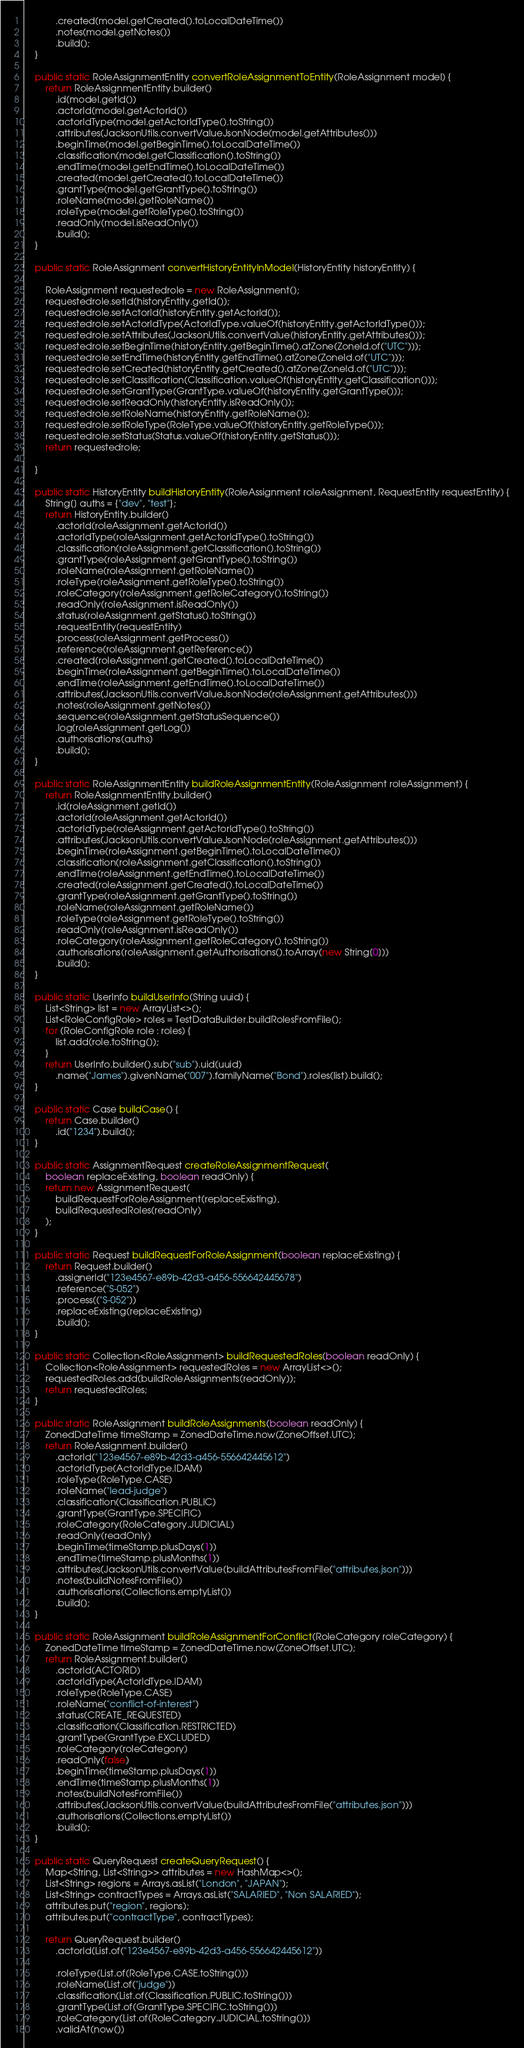Convert code to text. <code><loc_0><loc_0><loc_500><loc_500><_Java_>            .created(model.getCreated().toLocalDateTime())
            .notes(model.getNotes())
            .build();
    }

    public static RoleAssignmentEntity convertRoleAssignmentToEntity(RoleAssignment model) {
        return RoleAssignmentEntity.builder()
            .id(model.getId())
            .actorId(model.getActorId())
            .actorIdType(model.getActorIdType().toString())
            .attributes(JacksonUtils.convertValueJsonNode(model.getAttributes()))
            .beginTime(model.getBeginTime().toLocalDateTime())
            .classification(model.getClassification().toString())
            .endTime(model.getEndTime().toLocalDateTime())
            .created(model.getCreated().toLocalDateTime())
            .grantType(model.getGrantType().toString())
            .roleName(model.getRoleName())
            .roleType(model.getRoleType().toString())
            .readOnly(model.isReadOnly())
            .build();
    }

    public static RoleAssignment convertHistoryEntityInModel(HistoryEntity historyEntity) {

        RoleAssignment requestedrole = new RoleAssignment();
        requestedrole.setId(historyEntity.getId());
        requestedrole.setActorId(historyEntity.getActorId());
        requestedrole.setActorIdType(ActorIdType.valueOf(historyEntity.getActorIdType()));
        requestedrole.setAttributes(JacksonUtils.convertValue(historyEntity.getAttributes()));
        requestedrole.setBeginTime(historyEntity.getBeginTime().atZone(ZoneId.of("UTC")));
        requestedrole.setEndTime(historyEntity.getEndTime().atZone(ZoneId.of("UTC")));
        requestedrole.setCreated(historyEntity.getCreated().atZone(ZoneId.of("UTC")));
        requestedrole.setClassification(Classification.valueOf(historyEntity.getClassification()));
        requestedrole.setGrantType(GrantType.valueOf(historyEntity.getGrantType()));
        requestedrole.setReadOnly(historyEntity.isReadOnly());
        requestedrole.setRoleName(historyEntity.getRoleName());
        requestedrole.setRoleType(RoleType.valueOf(historyEntity.getRoleType()));
        requestedrole.setStatus(Status.valueOf(historyEntity.getStatus()));
        return requestedrole;

    }

    public static HistoryEntity buildHistoryEntity(RoleAssignment roleAssignment, RequestEntity requestEntity) {
        String[] auths = {"dev", "test"};
        return HistoryEntity.builder()
            .actorId(roleAssignment.getActorId())
            .actorIdType(roleAssignment.getActorIdType().toString())
            .classification(roleAssignment.getClassification().toString())
            .grantType(roleAssignment.getGrantType().toString())
            .roleName(roleAssignment.getRoleName())
            .roleType(roleAssignment.getRoleType().toString())
            .roleCategory(roleAssignment.getRoleCategory().toString())
            .readOnly(roleAssignment.isReadOnly())
            .status(roleAssignment.getStatus().toString())
            .requestEntity(requestEntity)
            .process(roleAssignment.getProcess())
            .reference(roleAssignment.getReference())
            .created(roleAssignment.getCreated().toLocalDateTime())
            .beginTime(roleAssignment.getBeginTime().toLocalDateTime())
            .endTime(roleAssignment.getEndTime().toLocalDateTime())
            .attributes(JacksonUtils.convertValueJsonNode(roleAssignment.getAttributes()))
            .notes(roleAssignment.getNotes())
            .sequence(roleAssignment.getStatusSequence())
            .log(roleAssignment.getLog())
            .authorisations(auths)
            .build();
    }

    public static RoleAssignmentEntity buildRoleAssignmentEntity(RoleAssignment roleAssignment) {
        return RoleAssignmentEntity.builder()
            .id(roleAssignment.getId())
            .actorId(roleAssignment.getActorId())
            .actorIdType(roleAssignment.getActorIdType().toString())
            .attributes(JacksonUtils.convertValueJsonNode(roleAssignment.getAttributes()))
            .beginTime(roleAssignment.getBeginTime().toLocalDateTime())
            .classification(roleAssignment.getClassification().toString())
            .endTime(roleAssignment.getEndTime().toLocalDateTime())
            .created(roleAssignment.getCreated().toLocalDateTime())
            .grantType(roleAssignment.getGrantType().toString())
            .roleName(roleAssignment.getRoleName())
            .roleType(roleAssignment.getRoleType().toString())
            .readOnly(roleAssignment.isReadOnly())
            .roleCategory(roleAssignment.getRoleCategory().toString())
            .authorisations(roleAssignment.getAuthorisations().toArray(new String[0]))
            .build();
    }

    public static UserInfo buildUserInfo(String uuid) {
        List<String> list = new ArrayList<>();
        List<RoleConfigRole> roles = TestDataBuilder.buildRolesFromFile();
        for (RoleConfigRole role : roles) {
            list.add(role.toString());
        }
        return UserInfo.builder().sub("sub").uid(uuid)
            .name("James").givenName("007").familyName("Bond").roles(list).build();
    }

    public static Case buildCase() {
        return Case.builder()
            .id("1234").build();
    }

    public static AssignmentRequest createRoleAssignmentRequest(
        boolean replaceExisting, boolean readOnly) {
        return new AssignmentRequest(
            buildRequestForRoleAssignment(replaceExisting),
            buildRequestedRoles(readOnly)
        );
    }

    public static Request buildRequestForRoleAssignment(boolean replaceExisting) {
        return Request.builder()
            .assignerId("123e4567-e89b-42d3-a456-556642445678")
            .reference("S-052")
            .process(("S-052"))
            .replaceExisting(replaceExisting)
            .build();
    }

    public static Collection<RoleAssignment> buildRequestedRoles(boolean readOnly) {
        Collection<RoleAssignment> requestedRoles = new ArrayList<>();
        requestedRoles.add(buildRoleAssignments(readOnly));
        return requestedRoles;
    }

    public static RoleAssignment buildRoleAssignments(boolean readOnly) {
        ZonedDateTime timeStamp = ZonedDateTime.now(ZoneOffset.UTC);
        return RoleAssignment.builder()
            .actorId("123e4567-e89b-42d3-a456-556642445612")
            .actorIdType(ActorIdType.IDAM)
            .roleType(RoleType.CASE)
            .roleName("lead-judge")
            .classification(Classification.PUBLIC)
            .grantType(GrantType.SPECIFIC)
            .roleCategory(RoleCategory.JUDICIAL)
            .readOnly(readOnly)
            .beginTime(timeStamp.plusDays(1))
            .endTime(timeStamp.plusMonths(1))
            .attributes(JacksonUtils.convertValue(buildAttributesFromFile("attributes.json")))
            .notes(buildNotesFromFile())
            .authorisations(Collections.emptyList())
            .build();
    }

    public static RoleAssignment buildRoleAssignmentForConflict(RoleCategory roleCategory) {
        ZonedDateTime timeStamp = ZonedDateTime.now(ZoneOffset.UTC);
        return RoleAssignment.builder()
            .actorId(ACTORID)
            .actorIdType(ActorIdType.IDAM)
            .roleType(RoleType.CASE)
            .roleName("conflict-of-interest")
            .status(CREATE_REQUESTED)
            .classification(Classification.RESTRICTED)
            .grantType(GrantType.EXCLUDED)
            .roleCategory(roleCategory)
            .readOnly(false)
            .beginTime(timeStamp.plusDays(1))
            .endTime(timeStamp.plusMonths(1))
            .notes(buildNotesFromFile())
            .attributes(JacksonUtils.convertValue(buildAttributesFromFile("attributes.json")))
            .authorisations(Collections.emptyList())
            .build();
    }

    public static QueryRequest createQueryRequest() {
        Map<String, List<String>> attributes = new HashMap<>();
        List<String> regions = Arrays.asList("London", "JAPAN");
        List<String> contractTypes = Arrays.asList("SALARIED", "Non SALARIED");
        attributes.put("region", regions);
        attributes.put("contractType", contractTypes);

        return QueryRequest.builder()
            .actorId(List.of("123e4567-e89b-42d3-a456-556642445612"))

            .roleType(List.of(RoleType.CASE.toString()))
            .roleName(List.of("judge"))
            .classification(List.of(Classification.PUBLIC.toString()))
            .grantType(List.of(GrantType.SPECIFIC.toString()))
            .roleCategory(List.of(RoleCategory.JUDICIAL.toString()))
            .validAt(now())</code> 